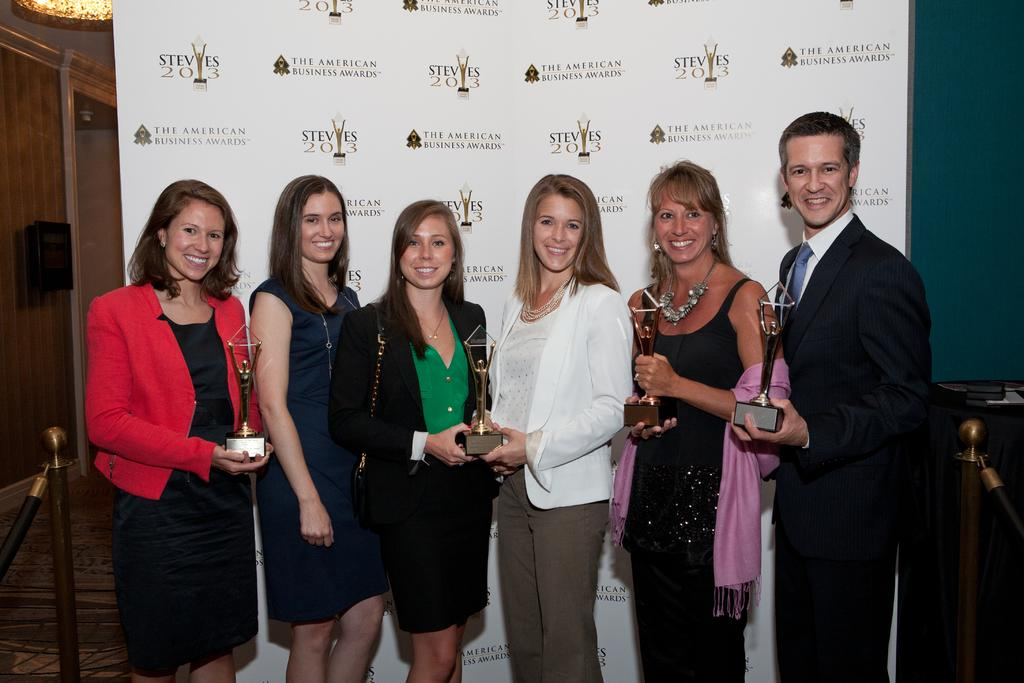What is the gender composition of the people in the image? Most of the people in the image are women, but there is at least one man present. What is the general mood of the people in the image? The people in the image are smiling, which suggests a positive or happy mood. What can be seen in the background of the image? There is a flex visible in the background. What type of guitar can be seen being played by the frogs in the image? There are no frogs or guitars present in the image; it features people standing near a flex. What type of market is visible in the background of the image? There is no market visible in the background of the image; it features a flex. 